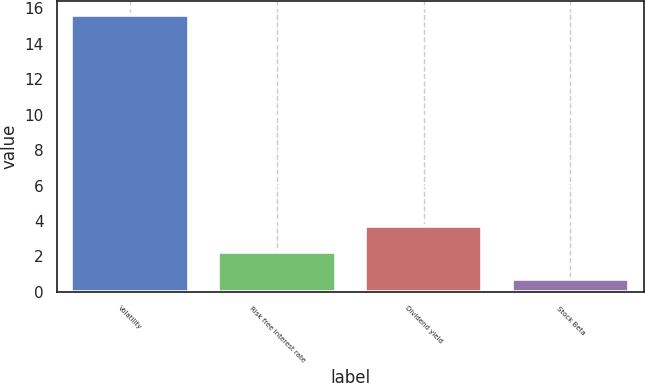<chart> <loc_0><loc_0><loc_500><loc_500><bar_chart><fcel>Volatility<fcel>Risk free interest rate<fcel>Dividend yield<fcel>Stock Beta<nl><fcel>15.6<fcel>2.23<fcel>3.72<fcel>0.74<nl></chart> 